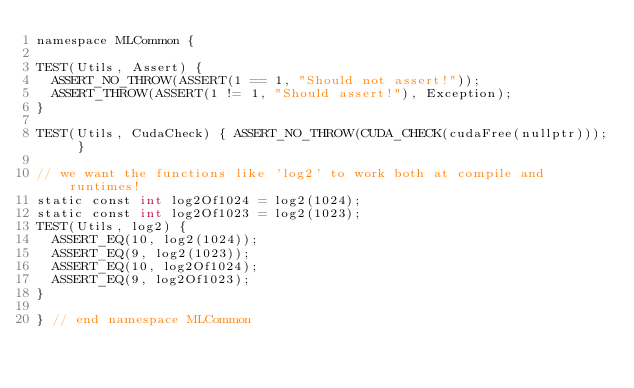<code> <loc_0><loc_0><loc_500><loc_500><_Cuda_>namespace MLCommon {

TEST(Utils, Assert) {
  ASSERT_NO_THROW(ASSERT(1 == 1, "Should not assert!"));
  ASSERT_THROW(ASSERT(1 != 1, "Should assert!"), Exception);
}

TEST(Utils, CudaCheck) { ASSERT_NO_THROW(CUDA_CHECK(cudaFree(nullptr))); }

// we want the functions like 'log2' to work both at compile and runtimes!
static const int log2Of1024 = log2(1024);
static const int log2Of1023 = log2(1023);
TEST(Utils, log2) {
  ASSERT_EQ(10, log2(1024));
  ASSERT_EQ(9, log2(1023));
  ASSERT_EQ(10, log2Of1024);
  ASSERT_EQ(9, log2Of1023);
}

} // end namespace MLCommon
</code> 